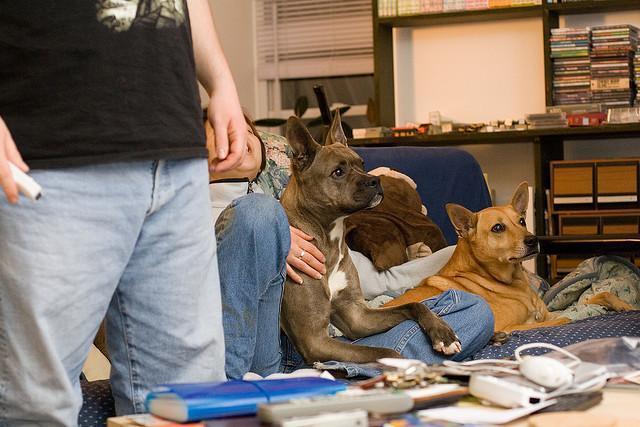Where are these people located?
Choose the correct response, then elucidate: 'Answer: answer
Rationale: rationale.'
Options: Work, hospital, library, home. Answer: home.
Rationale: The people are at home. 